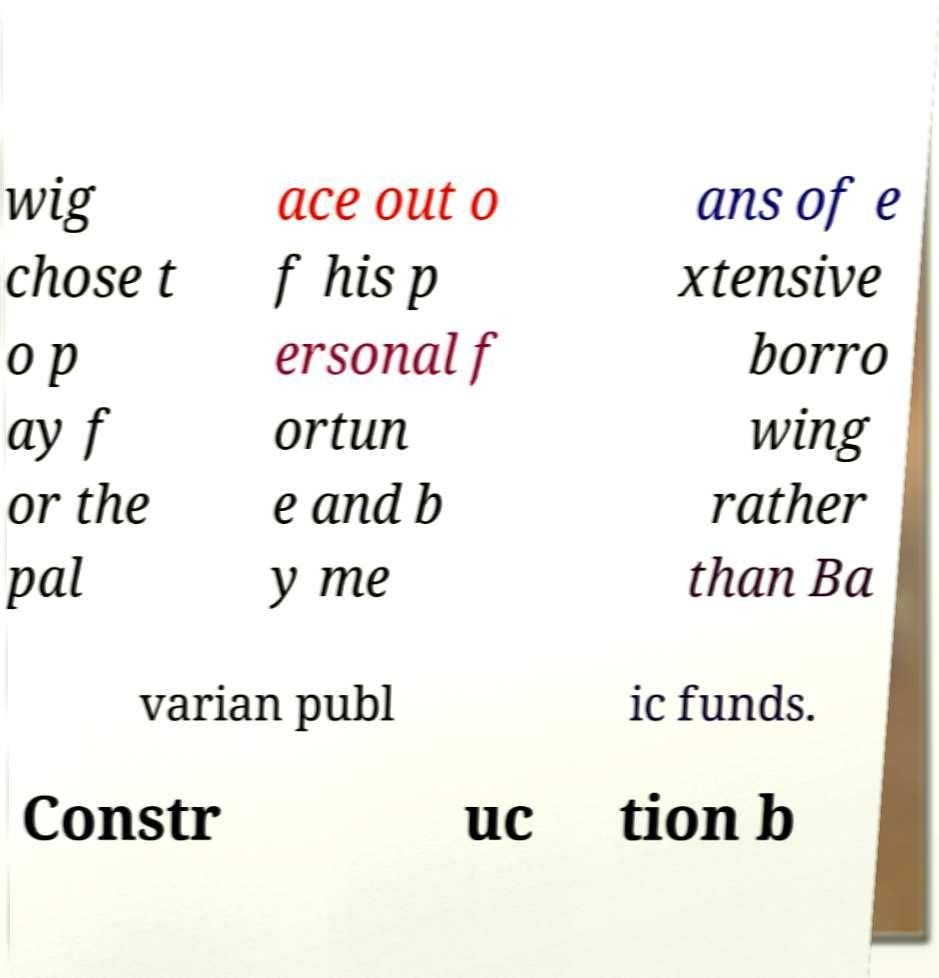Please read and relay the text visible in this image. What does it say? wig chose t o p ay f or the pal ace out o f his p ersonal f ortun e and b y me ans of e xtensive borro wing rather than Ba varian publ ic funds. Constr uc tion b 